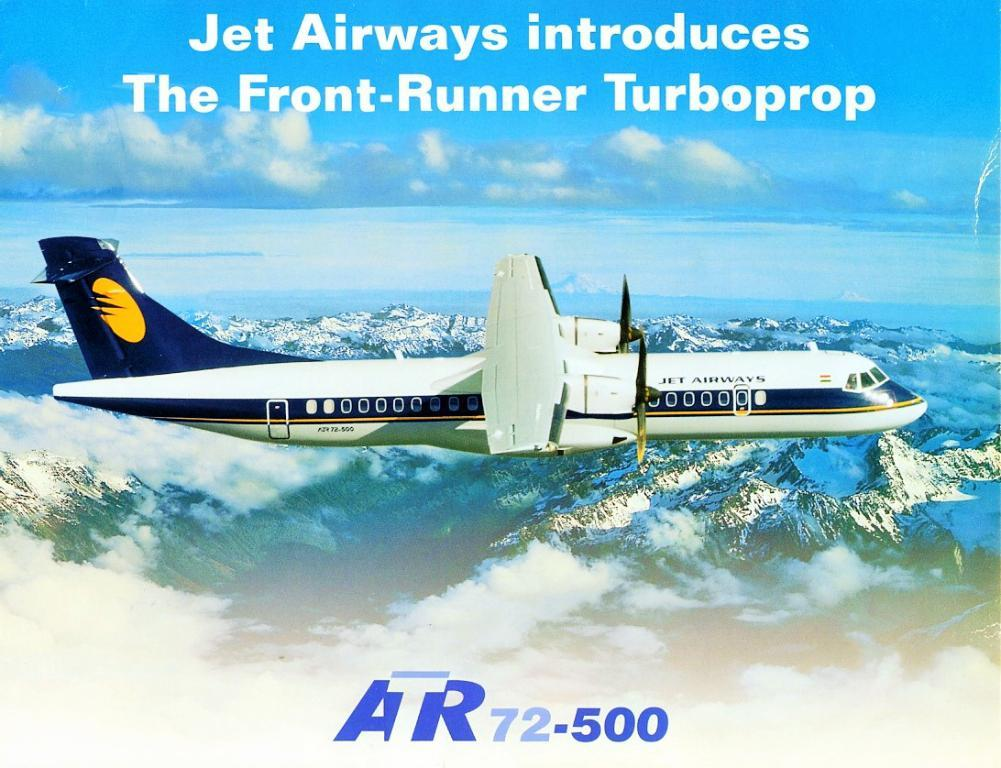What type of visual is the image? The image is a poster. What can be seen in the sky in the image? There are clouds visible in the sky. What mode of transportation is present in the image? There is an airplane in the image. What type of landscape is depicted in the image? There are hills in the image. What additional information is present on the poster? There is some information present on the poster. Can you see a bee buzzing around the airplane in the image? There is no bee present in the image. What hand gestures are being used by the people in the image? There are no people present in the image, so no hand gestures can be observed. 